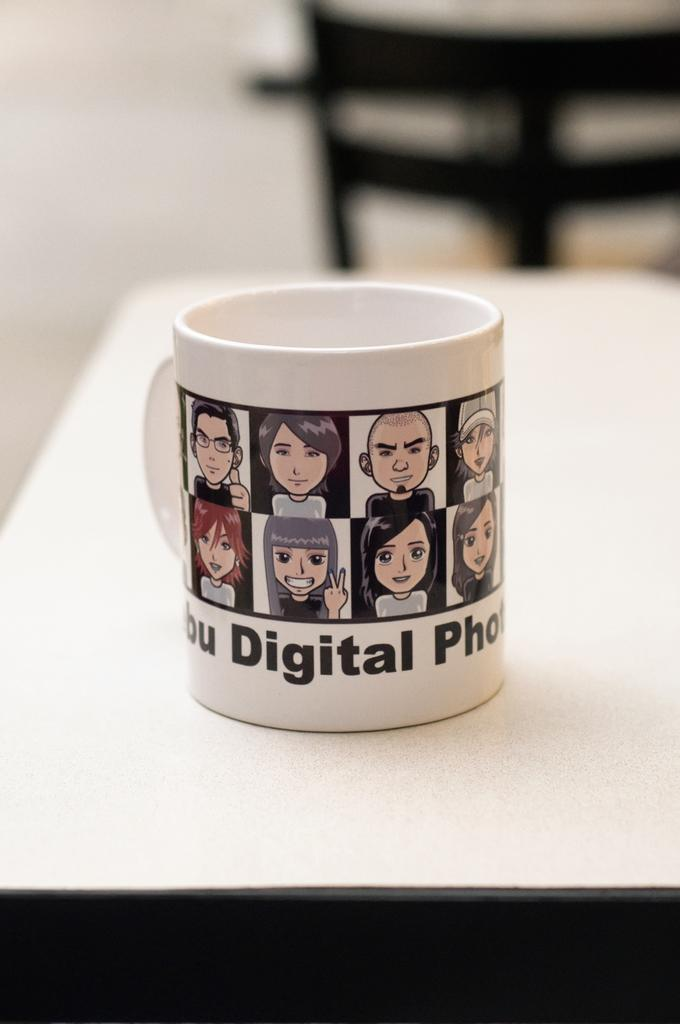<image>
Present a compact description of the photo's key features. A mug with some anime faces on it that says digital photo. 